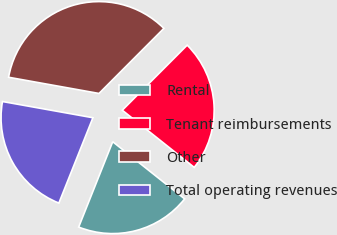Convert chart. <chart><loc_0><loc_0><loc_500><loc_500><pie_chart><fcel>Rental<fcel>Tenant reimbursements<fcel>Other<fcel>Total operating revenues<nl><fcel>20.35%<fcel>23.21%<fcel>34.65%<fcel>21.78%<nl></chart> 